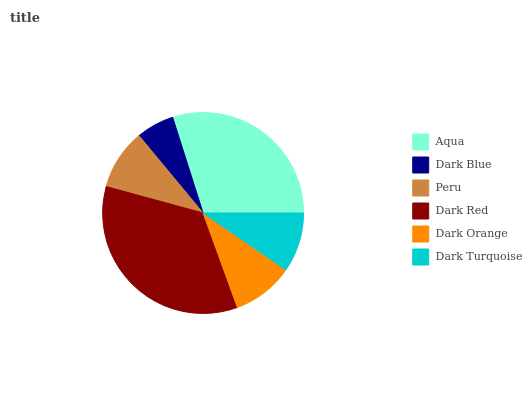Is Dark Blue the minimum?
Answer yes or no. Yes. Is Dark Red the maximum?
Answer yes or no. Yes. Is Peru the minimum?
Answer yes or no. No. Is Peru the maximum?
Answer yes or no. No. Is Peru greater than Dark Blue?
Answer yes or no. Yes. Is Dark Blue less than Peru?
Answer yes or no. Yes. Is Dark Blue greater than Peru?
Answer yes or no. No. Is Peru less than Dark Blue?
Answer yes or no. No. Is Dark Orange the high median?
Answer yes or no. Yes. Is Peru the low median?
Answer yes or no. Yes. Is Dark Turquoise the high median?
Answer yes or no. No. Is Dark Red the low median?
Answer yes or no. No. 